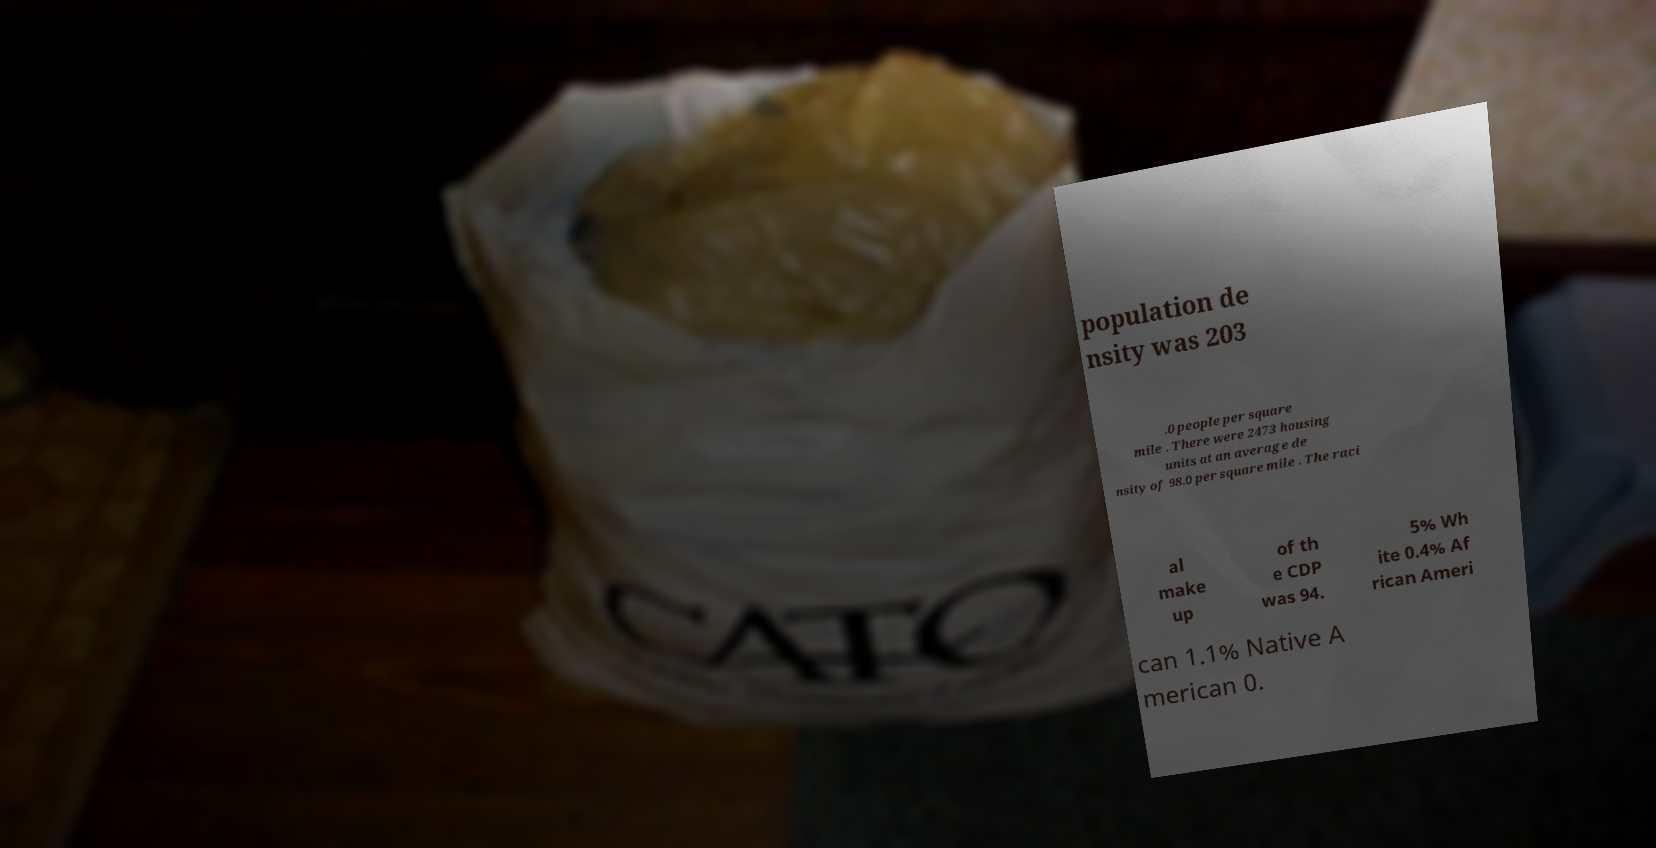There's text embedded in this image that I need extracted. Can you transcribe it verbatim? population de nsity was 203 .0 people per square mile . There were 2473 housing units at an average de nsity of 98.0 per square mile . The raci al make up of th e CDP was 94. 5% Wh ite 0.4% Af rican Ameri can 1.1% Native A merican 0. 